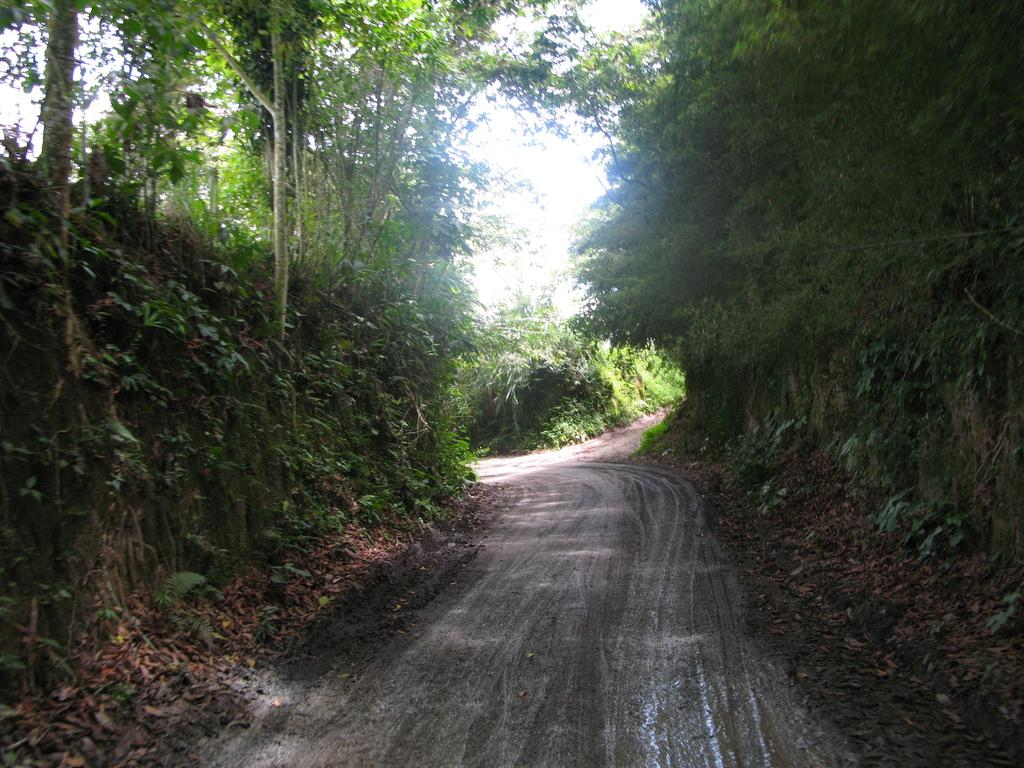What type of vegetation is present in the image? There are trees and plants in the image. What else can be seen in the image besides vegetation? There is a road in the image. What part of the natural environment is visible in the image? The sky is visible in the background of the image. Can you tell me how many toothbrushes are visible in the image? There are no toothbrushes present in the image. How many family members can be seen in the image? There is no reference to a family or any family members in the image. 